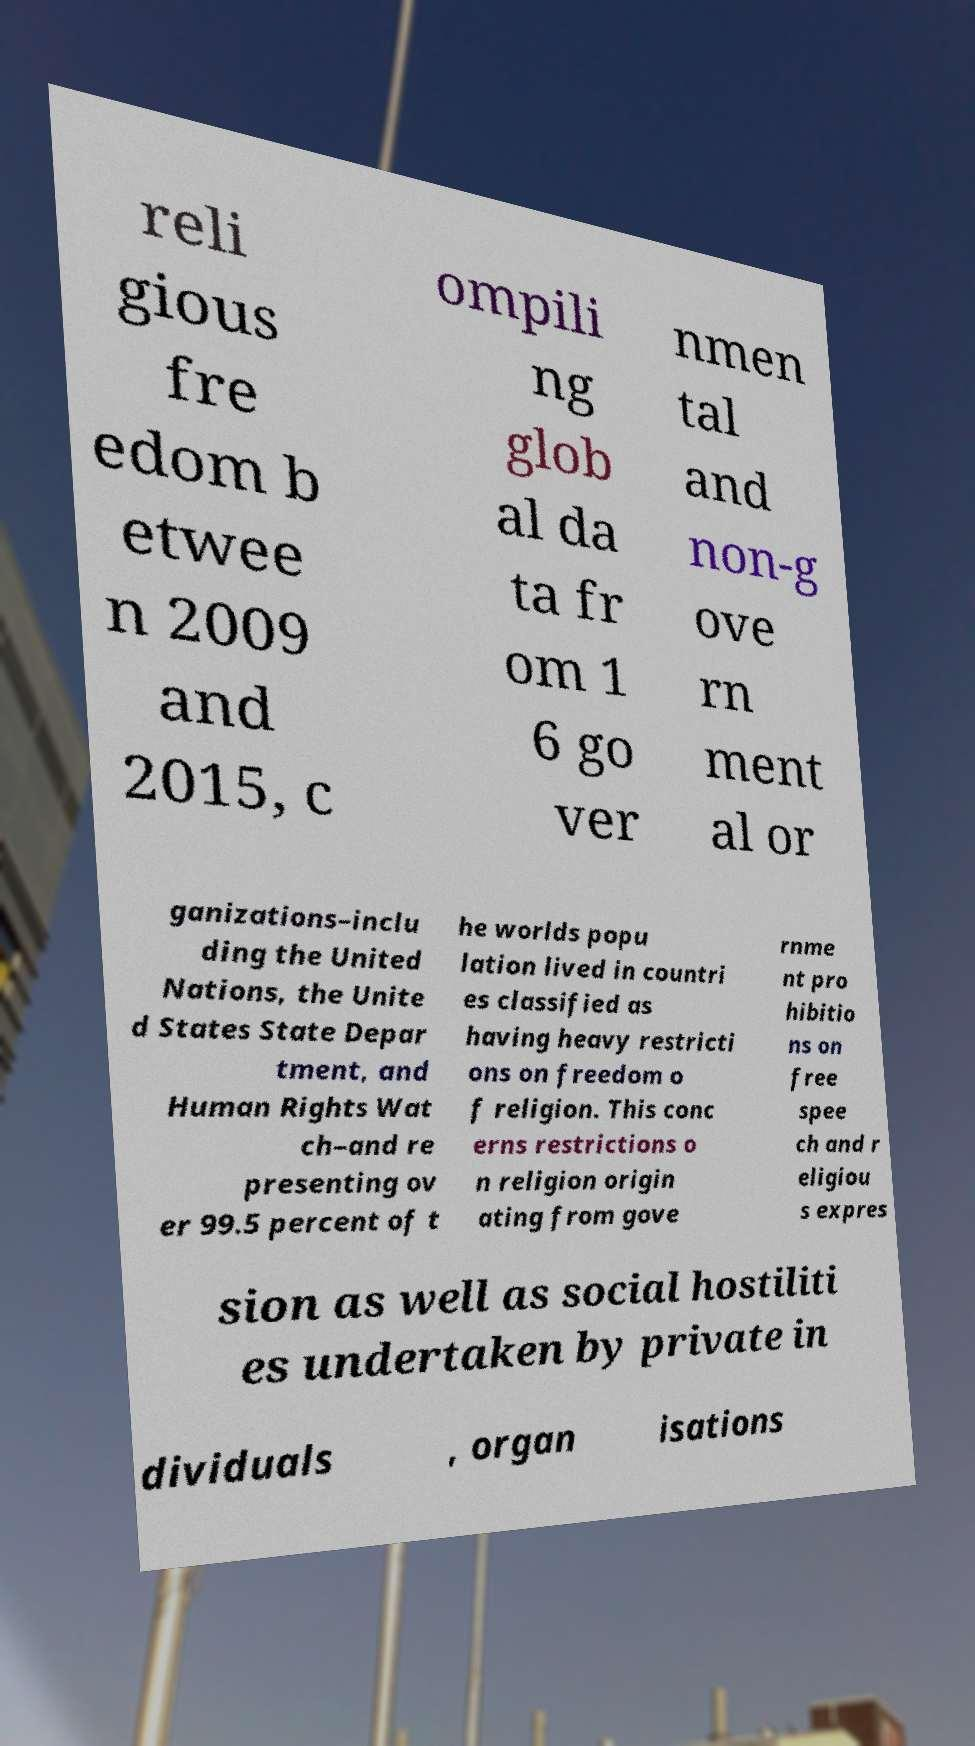Could you assist in decoding the text presented in this image and type it out clearly? reli gious fre edom b etwee n 2009 and 2015, c ompili ng glob al da ta fr om 1 6 go ver nmen tal and non-g ove rn ment al or ganizations–inclu ding the United Nations, the Unite d States State Depar tment, and Human Rights Wat ch–and re presenting ov er 99.5 percent of t he worlds popu lation lived in countri es classified as having heavy restricti ons on freedom o f religion. This conc erns restrictions o n religion origin ating from gove rnme nt pro hibitio ns on free spee ch and r eligiou s expres sion as well as social hostiliti es undertaken by private in dividuals , organ isations 